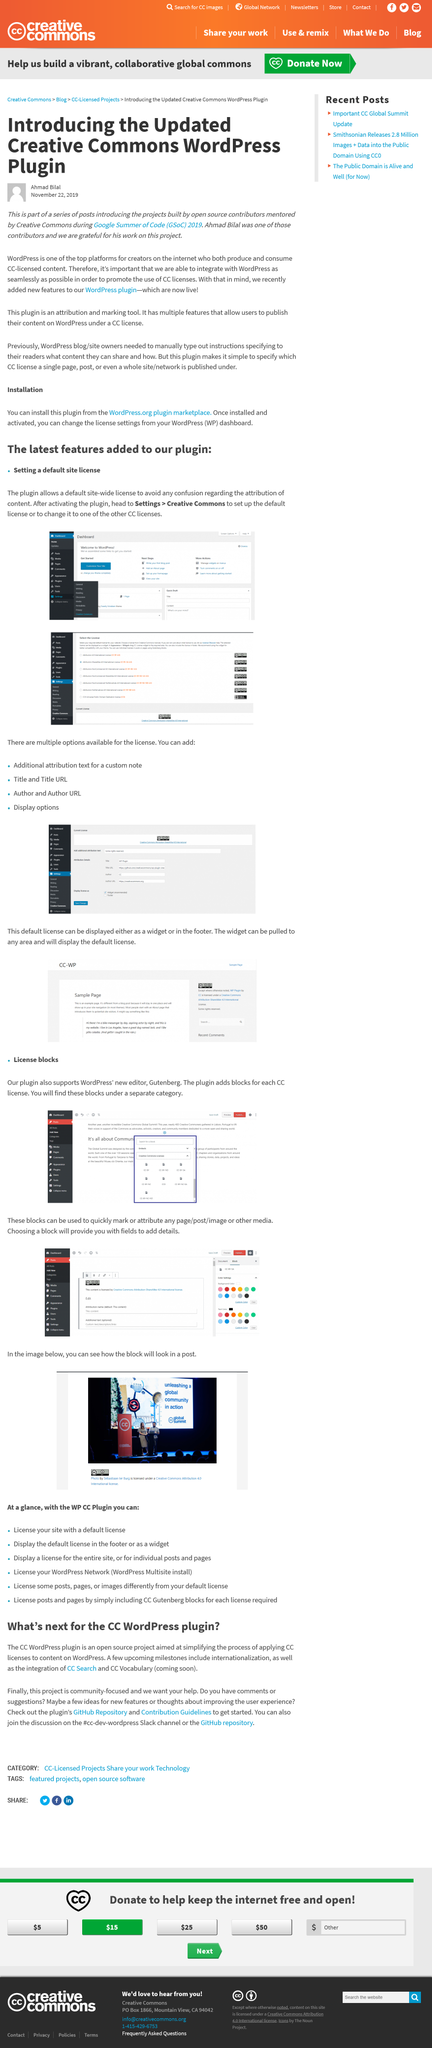Mention a couple of crucial points in this snapshot. The platform on which this content was published is WordPress. The article was published on November 22, 2019. It is permissible for individuals to discuss CC WordPress in the #cc-dev-wordpress Slack channel. Open source code can be found on the GitHub repository. Upcoming milestones for Wordpress include the internationalization and integration of CC search. 